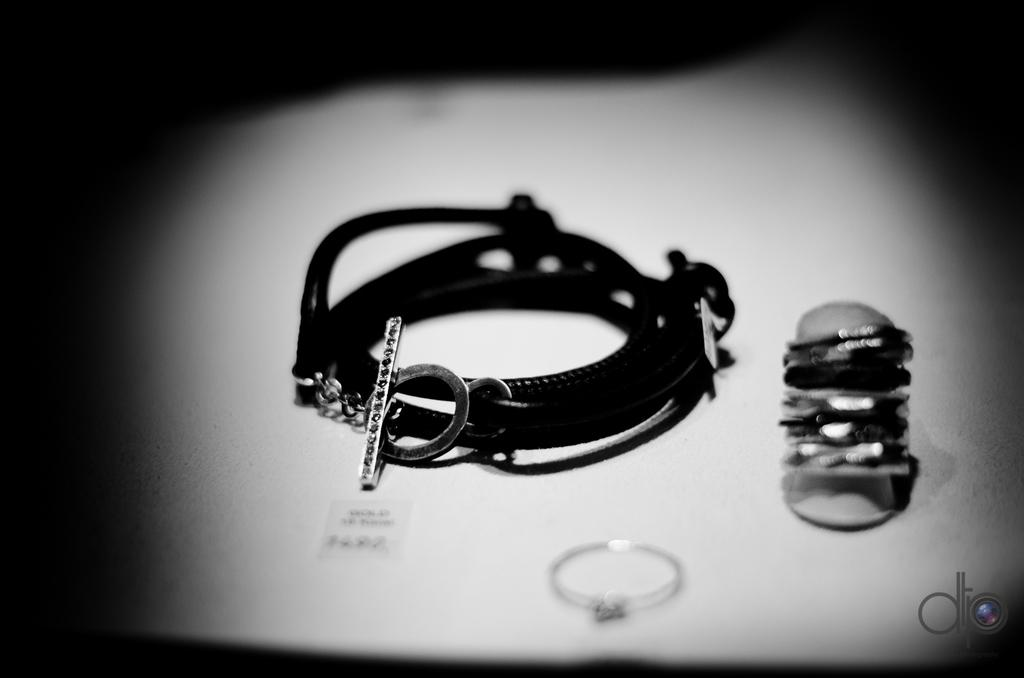What type of jewelry can be seen in the image? There is a bracelet and a finger ring in the image. Where are the jewelry items located? They are on a platform in the image. What is the color of the background in the image? The background of the image is dark. Is there any additional mark or feature in the image? Yes, there is a watermark in the bottom right corner of the image. Can you tell me how many people are stepping into the quicksand in the image? There is no quicksand or people stepping into it present in the image. What type of selection process is being depicted in the image? There is no selection process being depicted in the image; it features a bracelet, a finger ring, and a platform. 